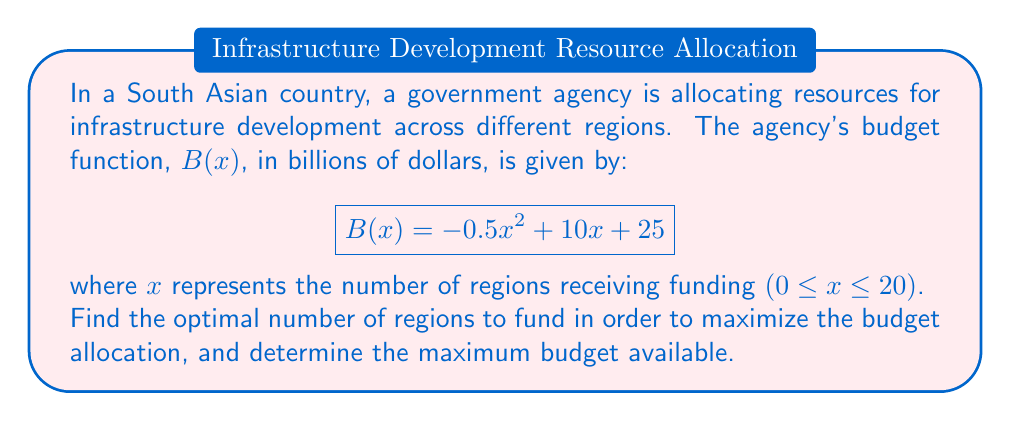Teach me how to tackle this problem. To find the optimal point for resource allocation, we need to find the maximum of the budget function $B(x)$. We can do this by finding the critical point using derivatives.

1. First, let's find the derivative of $B(x)$:
   $$B'(x) = -x + 10$$

2. To find the critical point, set $B'(x) = 0$:
   $$-x + 10 = 0$$
   $$x = 10$$

3. To confirm this is a maximum, we can check the second derivative:
   $$B''(x) = -1$$
   Since $B''(x)$ is negative, the critical point is indeed a maximum.

4. The optimal number of regions to fund is 10.

5. To find the maximum budget, we substitute $x = 10$ into the original function:
   $$B(10) = -0.5(10)^2 + 10(10) + 25$$
   $$= -50 + 100 + 25$$
   $$= 75$$

Therefore, the maximum budget available is 75 billion dollars.
Answer: The optimal number of regions to fund is 10, and the maximum budget available is $75 billion. 